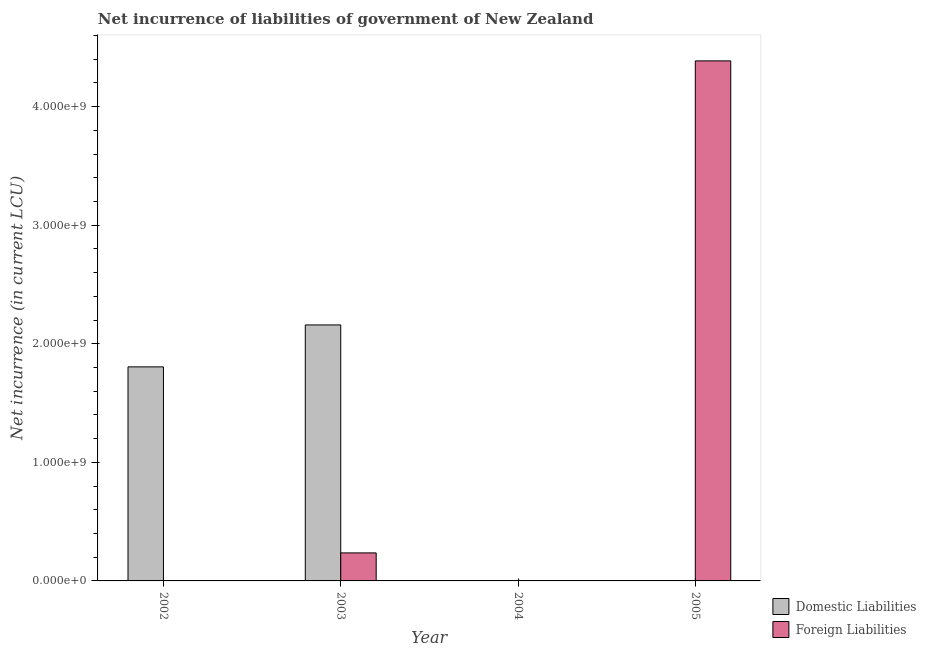How many bars are there on the 4th tick from the left?
Offer a terse response. 1. What is the label of the 4th group of bars from the left?
Provide a succinct answer. 2005. In how many cases, is the number of bars for a given year not equal to the number of legend labels?
Offer a terse response. 3. What is the net incurrence of foreign liabilities in 2005?
Your response must be concise. 4.39e+09. Across all years, what is the maximum net incurrence of domestic liabilities?
Offer a very short reply. 2.16e+09. In which year was the net incurrence of domestic liabilities maximum?
Offer a terse response. 2003. What is the total net incurrence of foreign liabilities in the graph?
Your answer should be very brief. 4.62e+09. What is the difference between the net incurrence of foreign liabilities in 2003 and that in 2005?
Offer a terse response. -4.15e+09. What is the difference between the net incurrence of foreign liabilities in 2005 and the net incurrence of domestic liabilities in 2004?
Make the answer very short. 4.39e+09. What is the average net incurrence of domestic liabilities per year?
Keep it short and to the point. 9.91e+08. What is the ratio of the net incurrence of domestic liabilities in 2002 to that in 2003?
Keep it short and to the point. 0.84. What is the difference between the highest and the lowest net incurrence of domestic liabilities?
Your answer should be compact. 2.16e+09. How many years are there in the graph?
Your response must be concise. 4. Are the values on the major ticks of Y-axis written in scientific E-notation?
Your answer should be compact. Yes. How many legend labels are there?
Provide a succinct answer. 2. How are the legend labels stacked?
Your response must be concise. Vertical. What is the title of the graph?
Your answer should be compact. Net incurrence of liabilities of government of New Zealand. Does "External balance on goods" appear as one of the legend labels in the graph?
Your answer should be compact. No. What is the label or title of the X-axis?
Make the answer very short. Year. What is the label or title of the Y-axis?
Your answer should be compact. Net incurrence (in current LCU). What is the Net incurrence (in current LCU) of Domestic Liabilities in 2002?
Ensure brevity in your answer.  1.81e+09. What is the Net incurrence (in current LCU) in Foreign Liabilities in 2002?
Provide a succinct answer. 0. What is the Net incurrence (in current LCU) in Domestic Liabilities in 2003?
Your answer should be very brief. 2.16e+09. What is the Net incurrence (in current LCU) in Foreign Liabilities in 2003?
Offer a very short reply. 2.36e+08. What is the Net incurrence (in current LCU) in Domestic Liabilities in 2005?
Your answer should be compact. 0. What is the Net incurrence (in current LCU) in Foreign Liabilities in 2005?
Your response must be concise. 4.39e+09. Across all years, what is the maximum Net incurrence (in current LCU) in Domestic Liabilities?
Your answer should be compact. 2.16e+09. Across all years, what is the maximum Net incurrence (in current LCU) of Foreign Liabilities?
Your answer should be very brief. 4.39e+09. Across all years, what is the minimum Net incurrence (in current LCU) in Domestic Liabilities?
Make the answer very short. 0. Across all years, what is the minimum Net incurrence (in current LCU) in Foreign Liabilities?
Your response must be concise. 0. What is the total Net incurrence (in current LCU) of Domestic Liabilities in the graph?
Provide a short and direct response. 3.96e+09. What is the total Net incurrence (in current LCU) of Foreign Liabilities in the graph?
Your answer should be very brief. 4.62e+09. What is the difference between the Net incurrence (in current LCU) in Domestic Liabilities in 2002 and that in 2003?
Give a very brief answer. -3.54e+08. What is the difference between the Net incurrence (in current LCU) of Foreign Liabilities in 2003 and that in 2005?
Keep it short and to the point. -4.15e+09. What is the difference between the Net incurrence (in current LCU) in Domestic Liabilities in 2002 and the Net incurrence (in current LCU) in Foreign Liabilities in 2003?
Keep it short and to the point. 1.57e+09. What is the difference between the Net incurrence (in current LCU) of Domestic Liabilities in 2002 and the Net incurrence (in current LCU) of Foreign Liabilities in 2005?
Offer a terse response. -2.58e+09. What is the difference between the Net incurrence (in current LCU) of Domestic Liabilities in 2003 and the Net incurrence (in current LCU) of Foreign Liabilities in 2005?
Your answer should be compact. -2.23e+09. What is the average Net incurrence (in current LCU) of Domestic Liabilities per year?
Ensure brevity in your answer.  9.91e+08. What is the average Net incurrence (in current LCU) in Foreign Liabilities per year?
Provide a short and direct response. 1.16e+09. In the year 2003, what is the difference between the Net incurrence (in current LCU) of Domestic Liabilities and Net incurrence (in current LCU) of Foreign Liabilities?
Keep it short and to the point. 1.92e+09. What is the ratio of the Net incurrence (in current LCU) in Domestic Liabilities in 2002 to that in 2003?
Your answer should be very brief. 0.84. What is the ratio of the Net incurrence (in current LCU) of Foreign Liabilities in 2003 to that in 2005?
Your response must be concise. 0.05. What is the difference between the highest and the lowest Net incurrence (in current LCU) in Domestic Liabilities?
Your answer should be compact. 2.16e+09. What is the difference between the highest and the lowest Net incurrence (in current LCU) of Foreign Liabilities?
Offer a very short reply. 4.39e+09. 